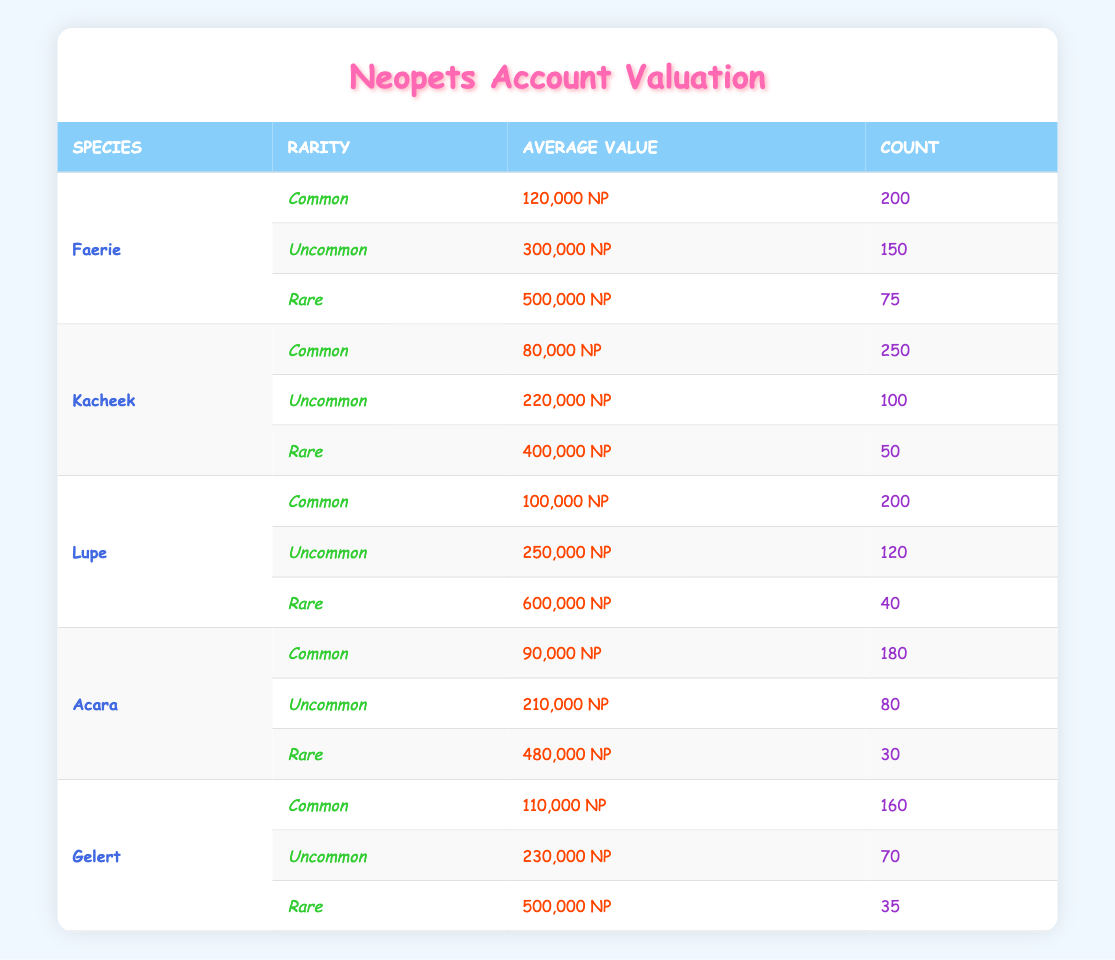What is the average value of a Common Faerie Neopet? The average value of a Common Faerie Neopet is provided directly in the table under the "Average Value" column for the Faerie species and Common rarity, which is 120,000 NP.
Answer: 120,000 NP How many Rare Gelerts are there? The count of Rare Gelerts can be found directly in the table, specifically looking at the Gelert species and Rare rarity, showing a count of 35.
Answer: 35 What species and rarity combination has the highest average value? To find this, we compare all average values from different species and rarity combinations in the table. The Rare Lupe has the highest average value at 600,000 NP.
Answer: Rare Lupe What is the total count of Uncommon Acara and Kacheek Neopets? We find the counts for Uncommon Acara and Kacheek Neopets in their respective sections. The Uncommon Acara count is 80, and the Uncommon Kacheek count is 100. Adding these gives us a total count of 80 + 100 = 180.
Answer: 180 Is the average value of a Common Kacheek higher than that of a Common Acara? Referring to the table, the average value of a Common Kacheek is 80,000 NP, whereas for a Common Acara, it is 90,000 NP. Since 80,000 is less than 90,000, the statement is false.
Answer: No What is the average value of all Rare Neopets combined? To calculate the average value of all Rare Neopets, we first sum the average values of the Rare pets: Faerie (500,000 NP), Kacheek (400,000 NP), Lupe (600,000 NP), Acara (480,000 NP), and Gelert (500,000 NP). The total is 500,000 + 400,000 + 600,000 + 480,000 + 500,000 = 2,480,000 NP. There are 5 Rare pets. Thus, the average is 2,480,000 / 5 = 496,000 NP.
Answer: 496,000 NP Are there more Common Kacheeks or Uncommon Lupes? The table shows that the count of Common Kacheeks is 250, while the count of Uncommon Lupes is 120. Since 250 is greater than 120, the answer is yes.
Answer: Yes Which species has the lowest average value for the Common rarity? By examining the average values for Common rarity across different species in the table, we see that the Common Kacheek has the lowest average value at 80,000 NP.
Answer: Kacheek 